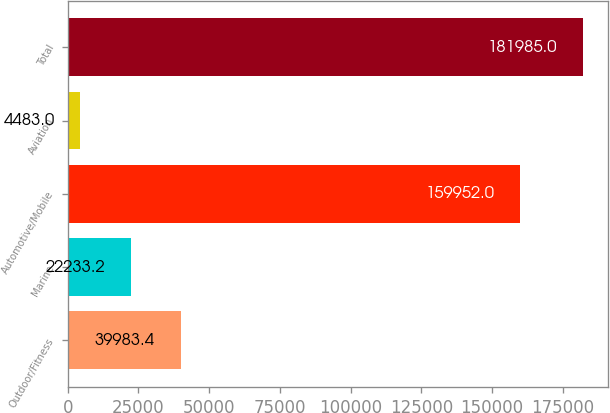<chart> <loc_0><loc_0><loc_500><loc_500><bar_chart><fcel>Outdoor/Fitness<fcel>Marine<fcel>Automotive/Mobile<fcel>Aviation<fcel>Total<nl><fcel>39983.4<fcel>22233.2<fcel>159952<fcel>4483<fcel>181985<nl></chart> 